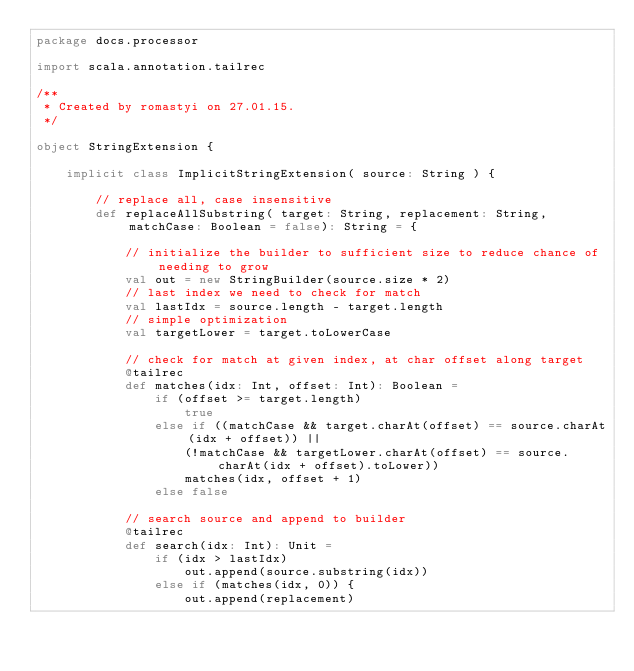<code> <loc_0><loc_0><loc_500><loc_500><_Scala_>package docs.processor

import scala.annotation.tailrec

/**
 * Created by romastyi on 27.01.15.
 */

object StringExtension {

    implicit class ImplicitStringExtension( source: String ) {

        // replace all, case insensitive
        def replaceAllSubstring( target: String, replacement: String, matchCase: Boolean = false): String = {

            // initialize the builder to sufficient size to reduce chance of needing to grow
            val out = new StringBuilder(source.size * 2)
            // last index we need to check for match
            val lastIdx = source.length - target.length
            // simple optimization
            val targetLower = target.toLowerCase

            // check for match at given index, at char offset along target
            @tailrec
            def matches(idx: Int, offset: Int): Boolean =
                if (offset >= target.length)
                    true
                else if ((matchCase && target.charAt(offset) == source.charAt(idx + offset)) ||
                    (!matchCase && targetLower.charAt(offset) == source.charAt(idx + offset).toLower))
                    matches(idx, offset + 1)
                else false

            // search source and append to builder
            @tailrec
            def search(idx: Int): Unit =
                if (idx > lastIdx)
                    out.append(source.substring(idx))
                else if (matches(idx, 0)) {
                    out.append(replacement)</code> 